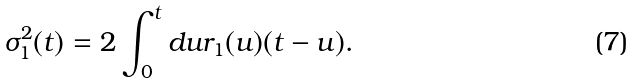Convert formula to latex. <formula><loc_0><loc_0><loc_500><loc_500>\sigma _ { 1 } ^ { 2 } ( t ) = 2 \int _ { 0 } ^ { t } d u r _ { 1 } ( u ) ( t - u ) .</formula> 